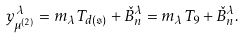Convert formula to latex. <formula><loc_0><loc_0><loc_500><loc_500>y _ { \mu ^ { ( 2 ) } } ^ { \lambda } = m _ { \lambda } T _ { d ( \mathfrak { s } ) } + \check { B } _ { n } ^ { \lambda } = m _ { \lambda } T _ { 9 } + \check { B } _ { n } ^ { \lambda } .</formula> 